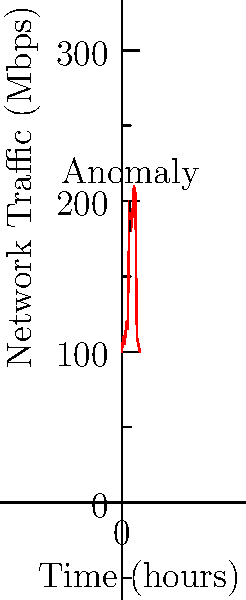Analyze the graph of network traffic patterns for an industrial control system (ICS) over a 12-hour period. What type of cybersecurity event does the sudden spike in traffic around hour 5 most likely indicate, and what immediate action should be taken? To analyze this graph and determine the most likely cybersecurity event, let's follow these steps:

1. Observe the overall pattern: The graph shows relatively stable network traffic around 100-120 Mbps for the first 4 hours.

2. Identify the anomaly: At approximately hour 5, there's a sudden and significant spike in network traffic, reaching about 200 Mbps.

3. Analyze the characteristics of the spike:
   - It's abrupt and nearly doubles the baseline traffic.
   - The elevated traffic persists for about 4 hours before returning to normal levels.

4. Consider common ICS cybersecurity threats:
   - DDoS attacks typically cause sustained high traffic.
   - Data exfiltration often shows as periodic spikes.
   - Malware propagation can cause sudden increases in traffic.

5. Interpret the pattern:
   The sudden spike followed by sustained high traffic for several hours is most consistent with a Distributed Denial of Service (DDoS) attack.

6. Determine immediate action:
   For a suspected DDoS attack on an ICS, the immediate action should be to activate the incident response plan, which typically includes:
   - Isolating affected systems
   - Implementing traffic filtering
   - Notifying relevant personnel and authorities

Given the critical nature of ICS environments, rapid response is crucial to maintain operational integrity and safety.
Answer: DDoS attack; activate incident response plan 